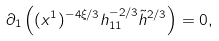Convert formula to latex. <formula><loc_0><loc_0><loc_500><loc_500>\partial _ { 1 } \left ( ( x ^ { 1 } ) ^ { - 4 \xi / 3 } h _ { 1 1 } ^ { - 2 / 3 } \tilde { h } ^ { 2 / 3 } \right ) = 0 ,</formula> 